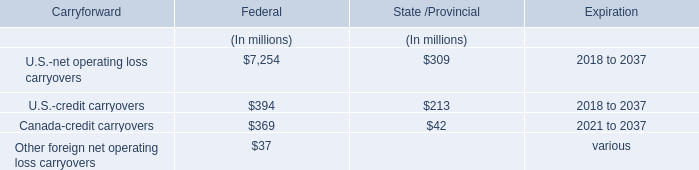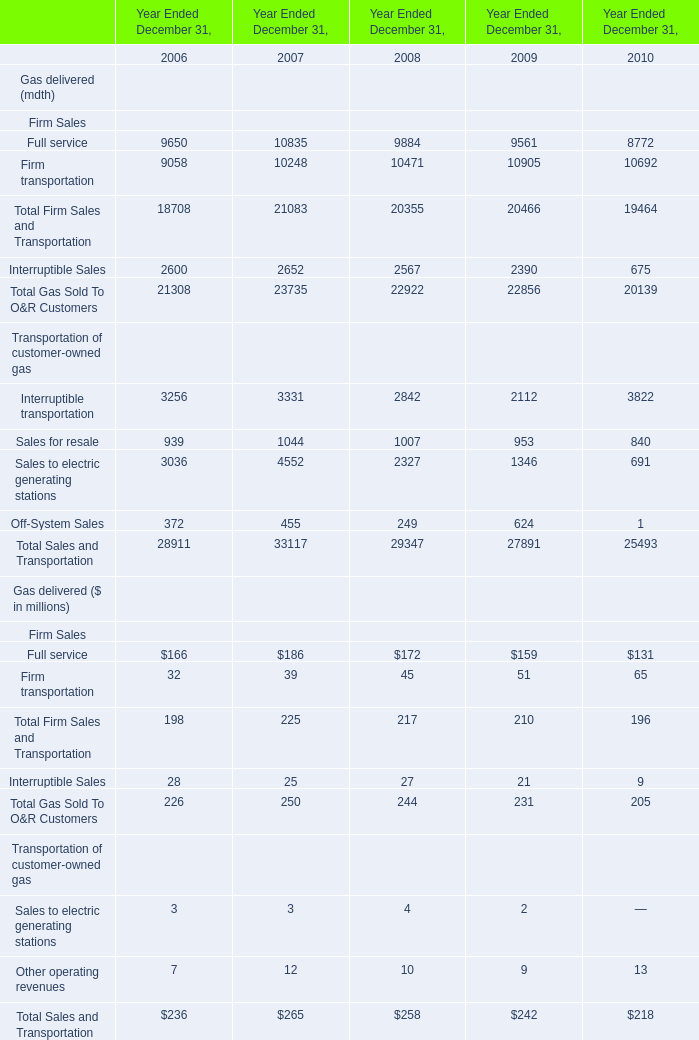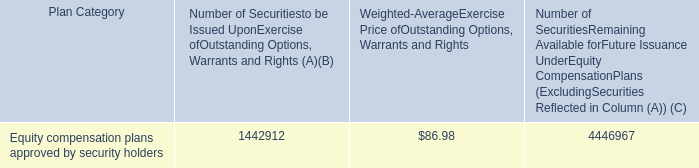Which year is Full service for Gas delivered ($ in millions) the highest? 
Answer: 2007. 